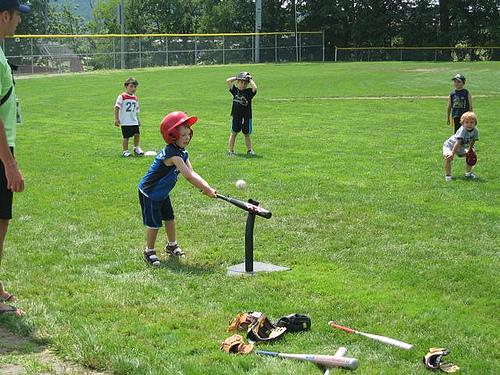How many bats are on the ground?
Concise answer only. 3. Is this little league?
Quick response, please. Yes. What was holding up the ball?
Be succinct. Tee. 